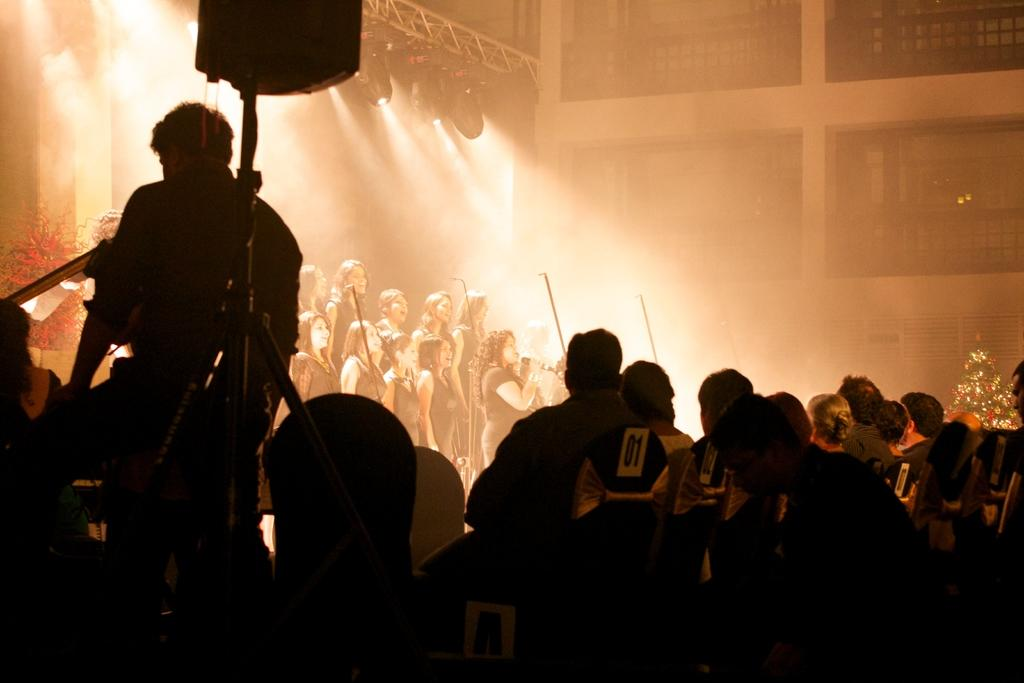How many people are in the image? There is a group of persons in the image. What are some of the persons doing in the image? Some of the persons are playing music. What can be seen at the top of the image? There is a focus of light at the top of the image. What type of structure is visible in the image? There is a wall visible in the image. What type of yard can be seen in the image? There is no yard present in the image. 